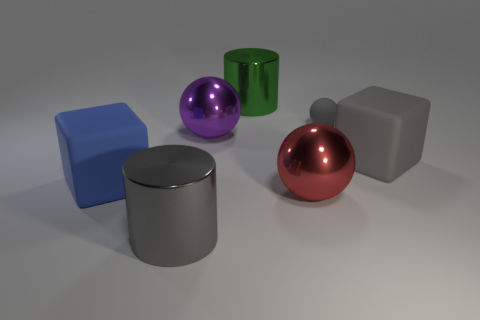Can you infer the relative positions of the objects in terms of depth? Certainly. The large red sphere seems to be positioned in the foreground due to its size and the way it overlaps the gray cylinder behind it. The purple object and the green cylinder appear to be in the middle ground, and the large matte blue cube is in the background, as it is partially obscured by the green cylinder. 